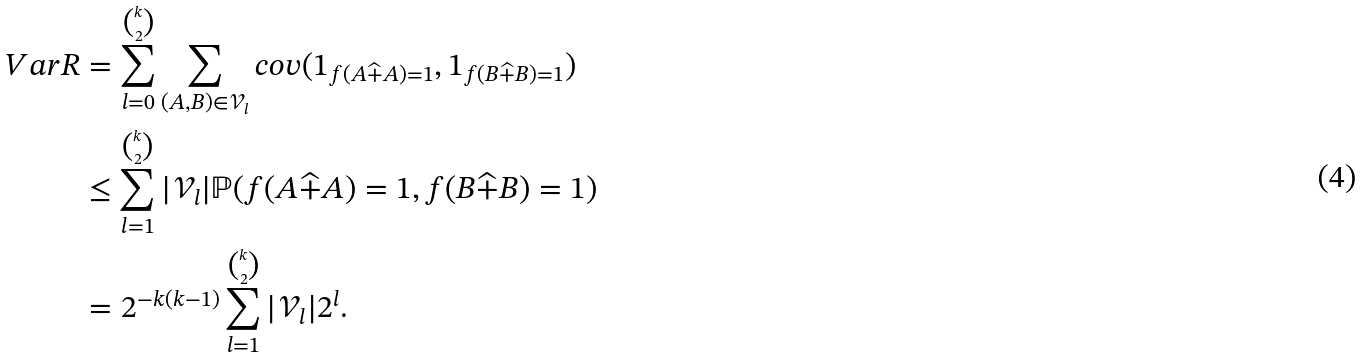Convert formula to latex. <formula><loc_0><loc_0><loc_500><loc_500>V a r R & = \sum _ { l = 0 } ^ { k \choose 2 } \sum _ { ( A , B ) \in \mathcal { V } _ { l } } c o v ( 1 _ { f ( A \widehat { + } A ) = 1 } , 1 _ { f ( B \widehat { + } B ) = 1 } ) \\ & \leq \sum _ { l = 1 } ^ { k \choose 2 } | \mathcal { V } _ { l } | \mathbb { P } ( f ( A \widehat { + } A ) = 1 , f ( B \widehat { + } B ) = 1 ) \\ & = 2 ^ { - k ( k - 1 ) } \sum _ { l = 1 } ^ { k \choose 2 } | \mathcal { V } _ { l } | 2 ^ { l } .</formula> 